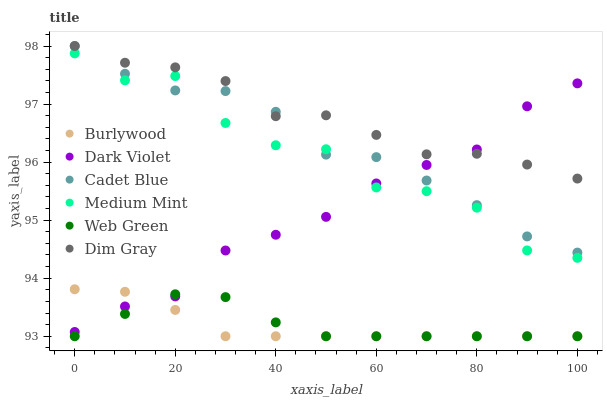Does Burlywood have the minimum area under the curve?
Answer yes or no. Yes. Does Dim Gray have the maximum area under the curve?
Answer yes or no. Yes. Does Dim Gray have the minimum area under the curve?
Answer yes or no. No. Does Burlywood have the maximum area under the curve?
Answer yes or no. No. Is Burlywood the smoothest?
Answer yes or no. Yes. Is Medium Mint the roughest?
Answer yes or no. Yes. Is Dim Gray the smoothest?
Answer yes or no. No. Is Dim Gray the roughest?
Answer yes or no. No. Does Burlywood have the lowest value?
Answer yes or no. Yes. Does Dim Gray have the lowest value?
Answer yes or no. No. Does Cadet Blue have the highest value?
Answer yes or no. Yes. Does Burlywood have the highest value?
Answer yes or no. No. Is Web Green less than Cadet Blue?
Answer yes or no. Yes. Is Medium Mint greater than Web Green?
Answer yes or no. Yes. Does Cadet Blue intersect Dark Violet?
Answer yes or no. Yes. Is Cadet Blue less than Dark Violet?
Answer yes or no. No. Is Cadet Blue greater than Dark Violet?
Answer yes or no. No. Does Web Green intersect Cadet Blue?
Answer yes or no. No. 